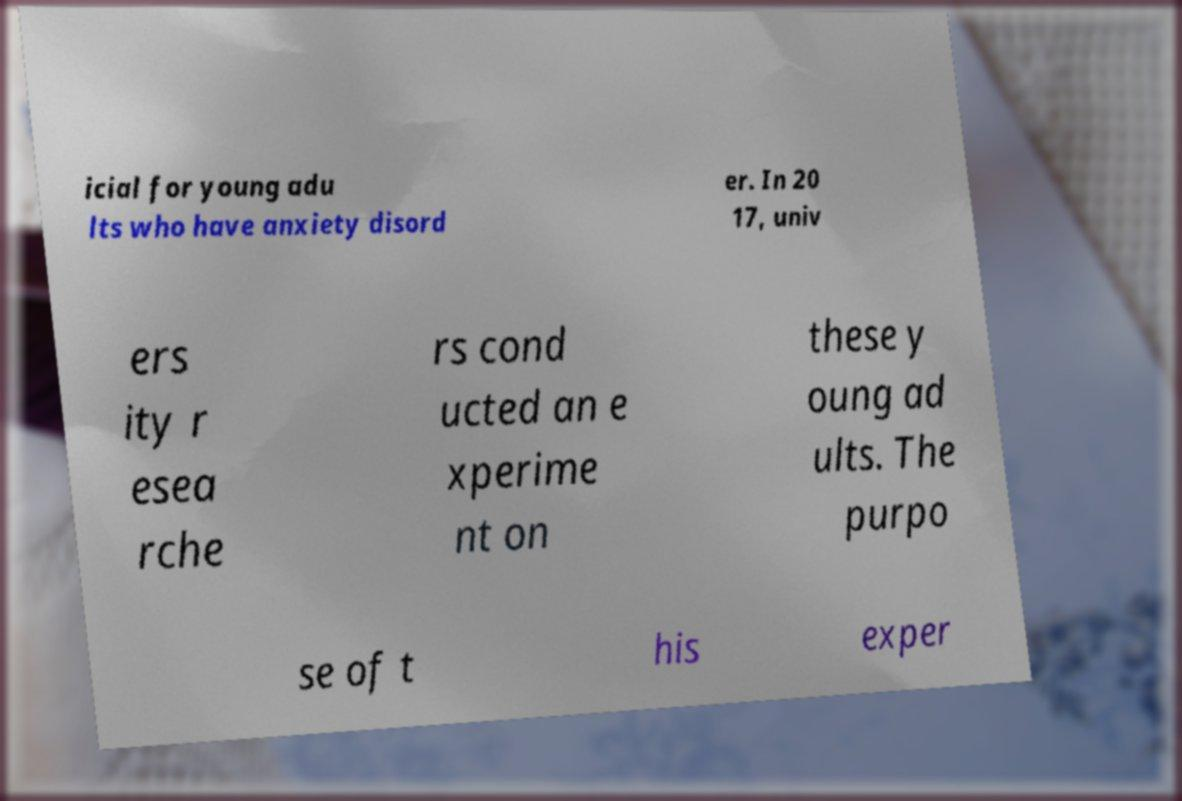Could you assist in decoding the text presented in this image and type it out clearly? icial for young adu lts who have anxiety disord er. In 20 17, univ ers ity r esea rche rs cond ucted an e xperime nt on these y oung ad ults. The purpo se of t his exper 